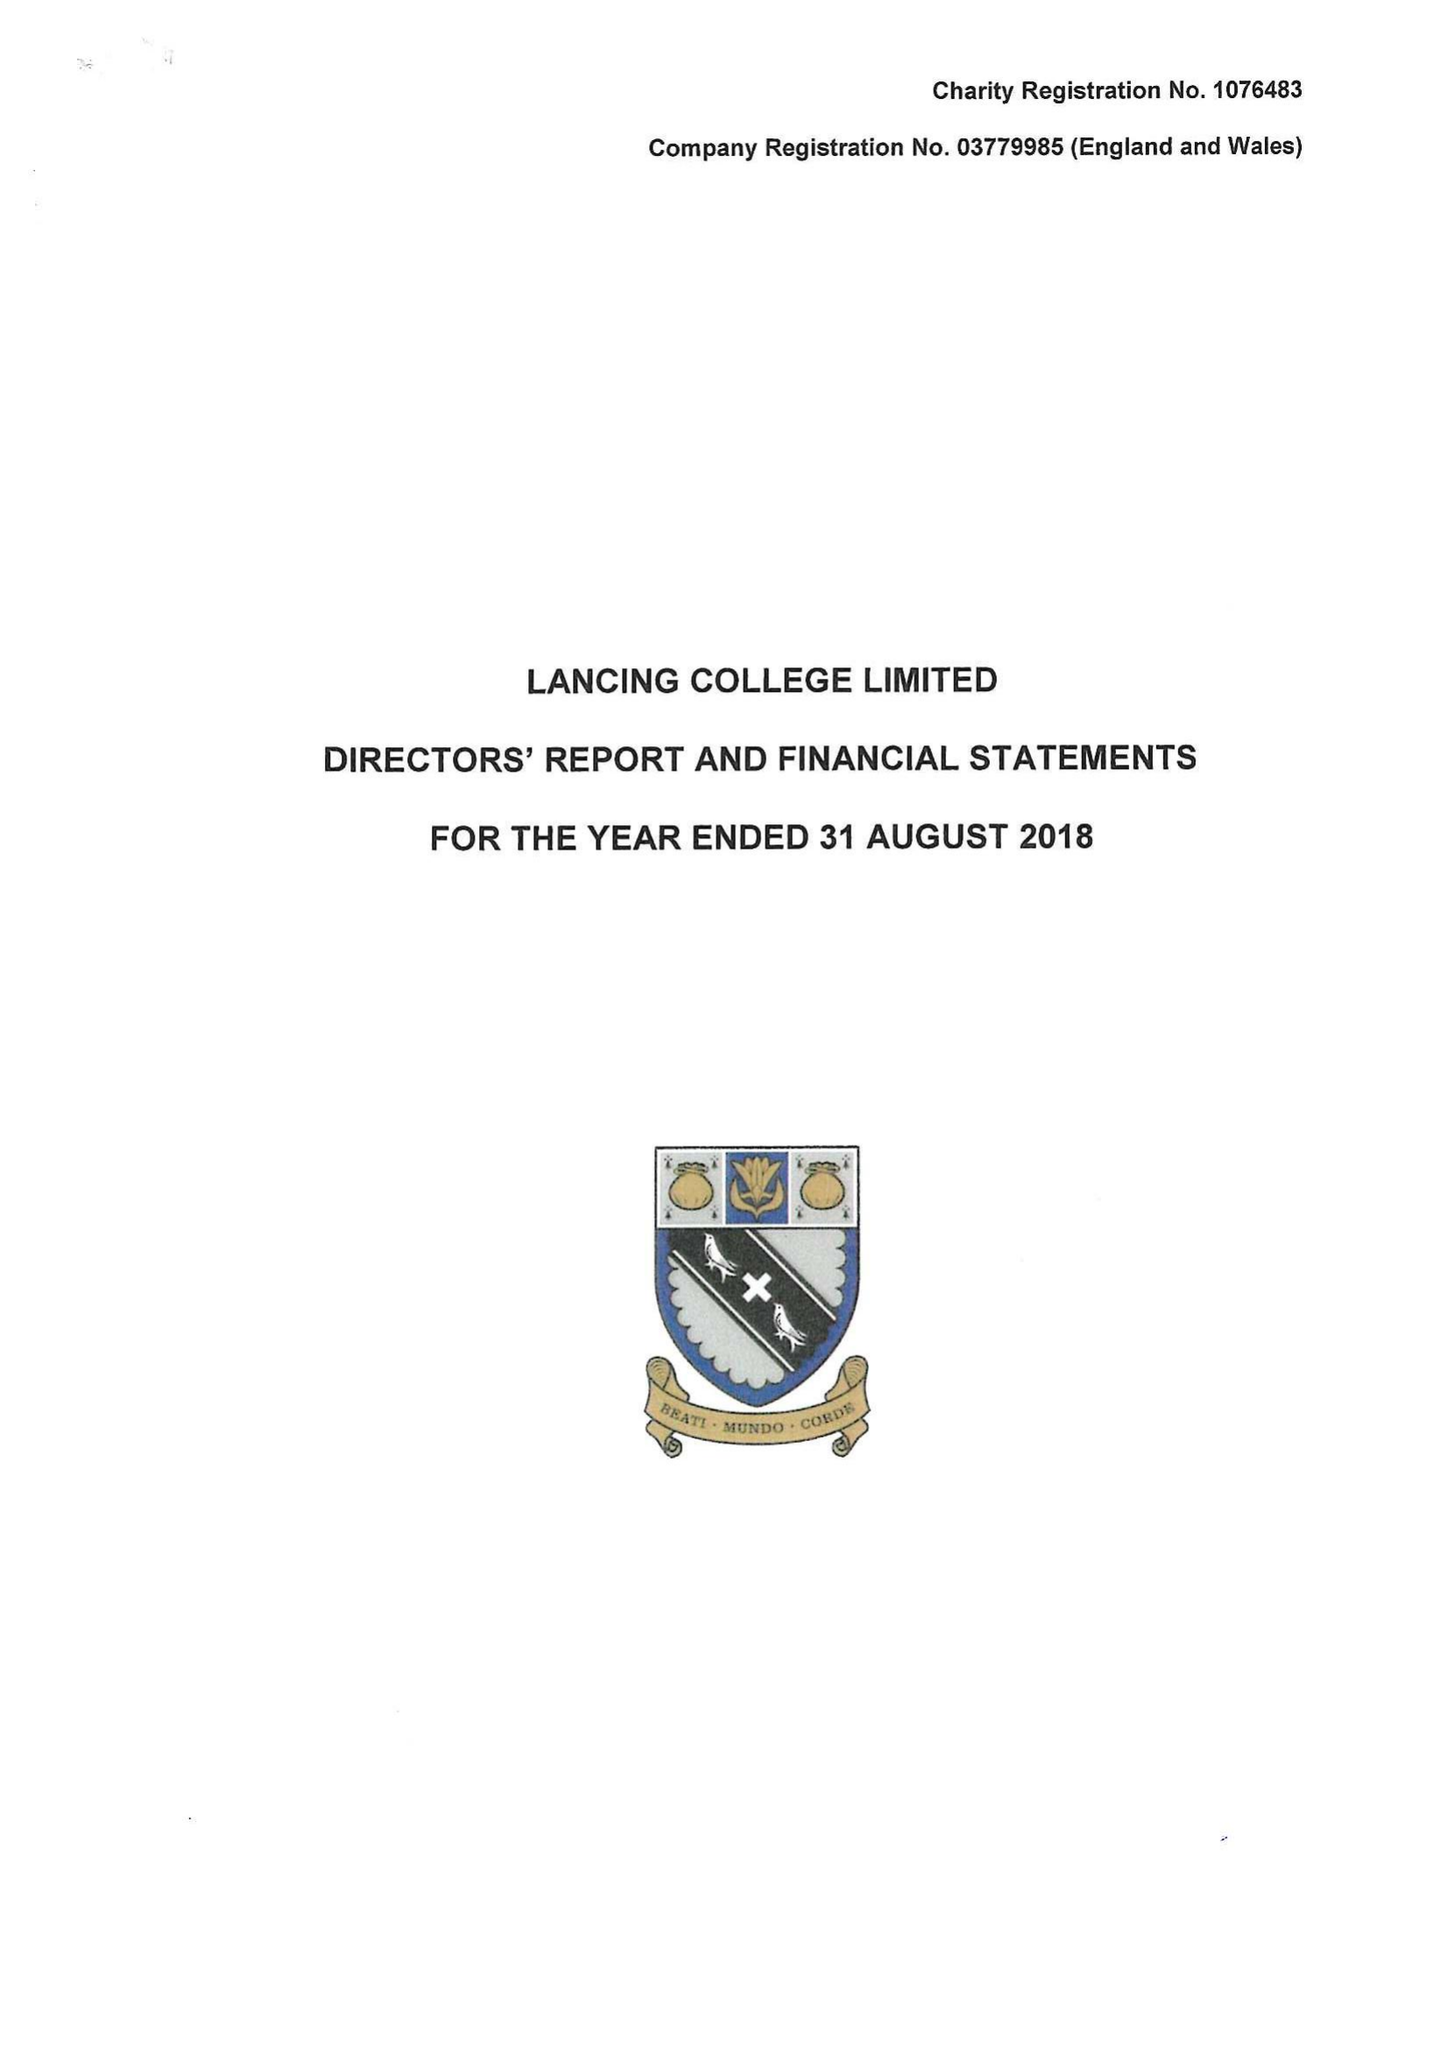What is the value for the address__post_town?
Answer the question using a single word or phrase. LANCING 